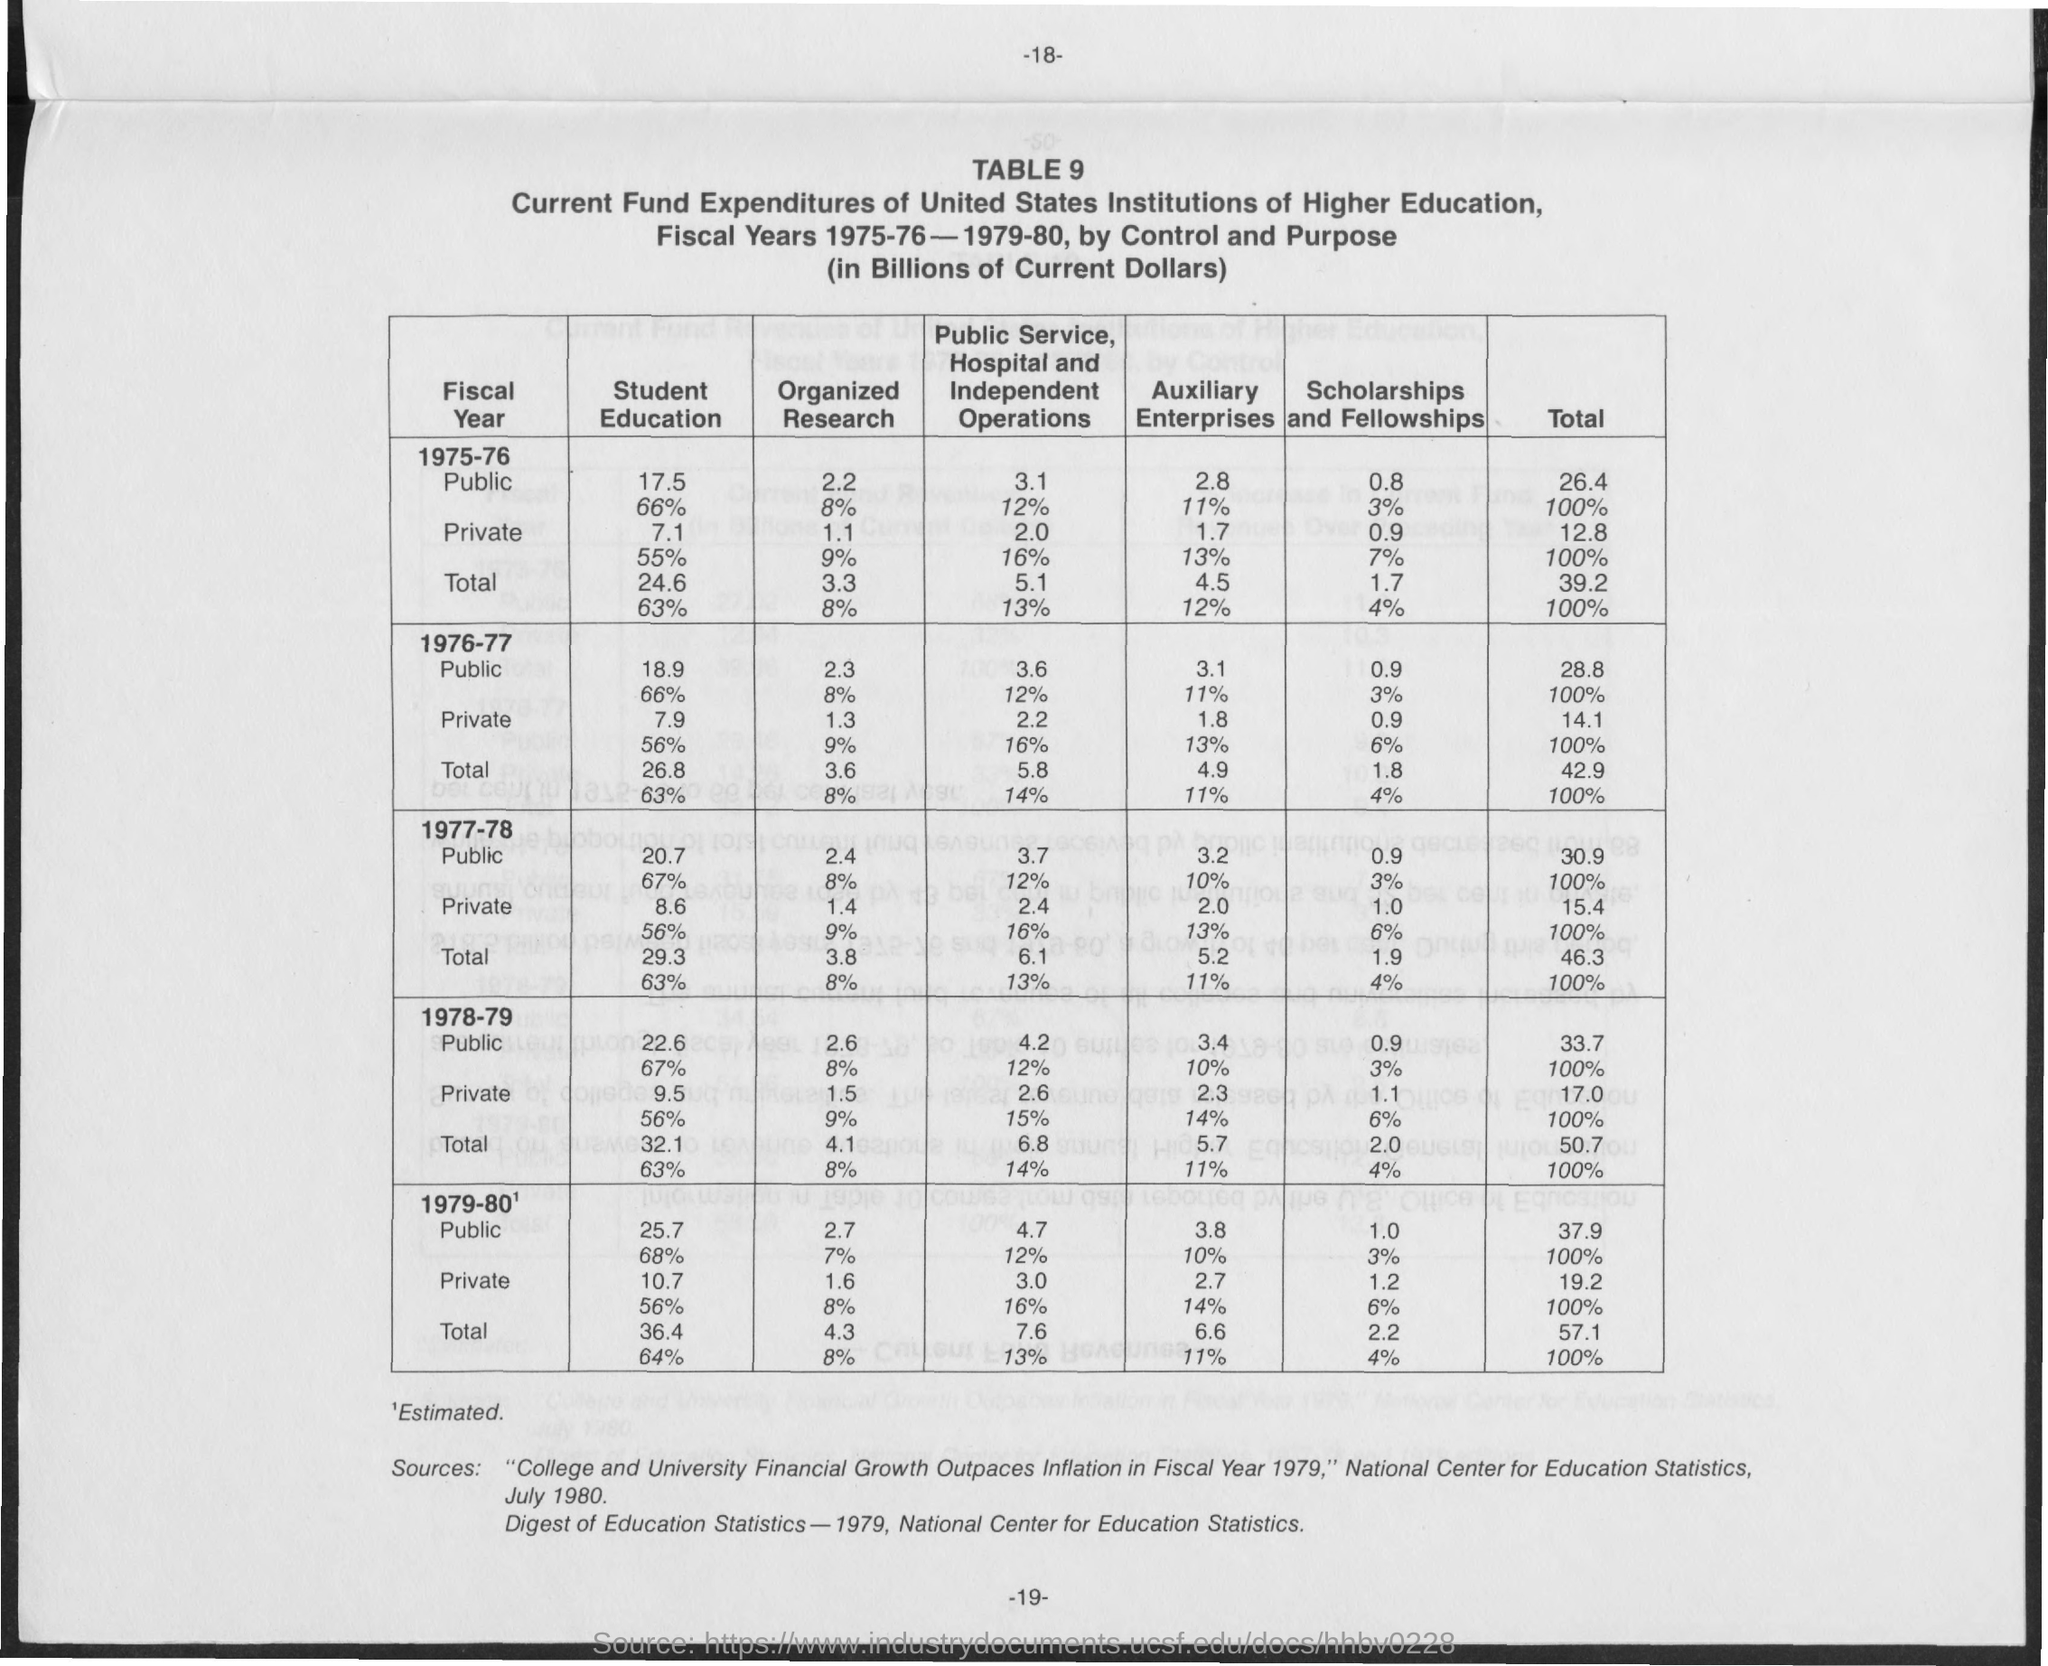Point out several critical features in this image. The page number is -18-. 